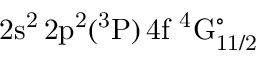<formula> <loc_0><loc_0><loc_500><loc_500>2 s ^ { 2 } \, 2 p ^ { 2 } ( ^ { 3 } P ) \, 4 f ^ { 4 } G _ { 1 1 / 2 } ^ { \circ }</formula> 